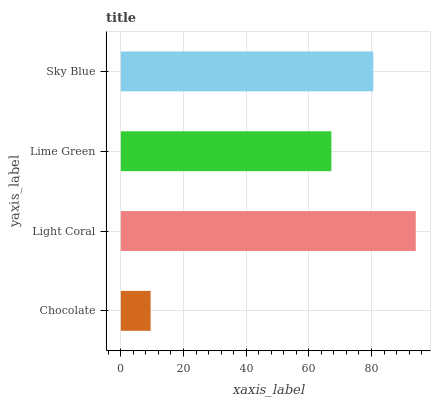Is Chocolate the minimum?
Answer yes or no. Yes. Is Light Coral the maximum?
Answer yes or no. Yes. Is Lime Green the minimum?
Answer yes or no. No. Is Lime Green the maximum?
Answer yes or no. No. Is Light Coral greater than Lime Green?
Answer yes or no. Yes. Is Lime Green less than Light Coral?
Answer yes or no. Yes. Is Lime Green greater than Light Coral?
Answer yes or no. No. Is Light Coral less than Lime Green?
Answer yes or no. No. Is Sky Blue the high median?
Answer yes or no. Yes. Is Lime Green the low median?
Answer yes or no. Yes. Is Light Coral the high median?
Answer yes or no. No. Is Sky Blue the low median?
Answer yes or no. No. 